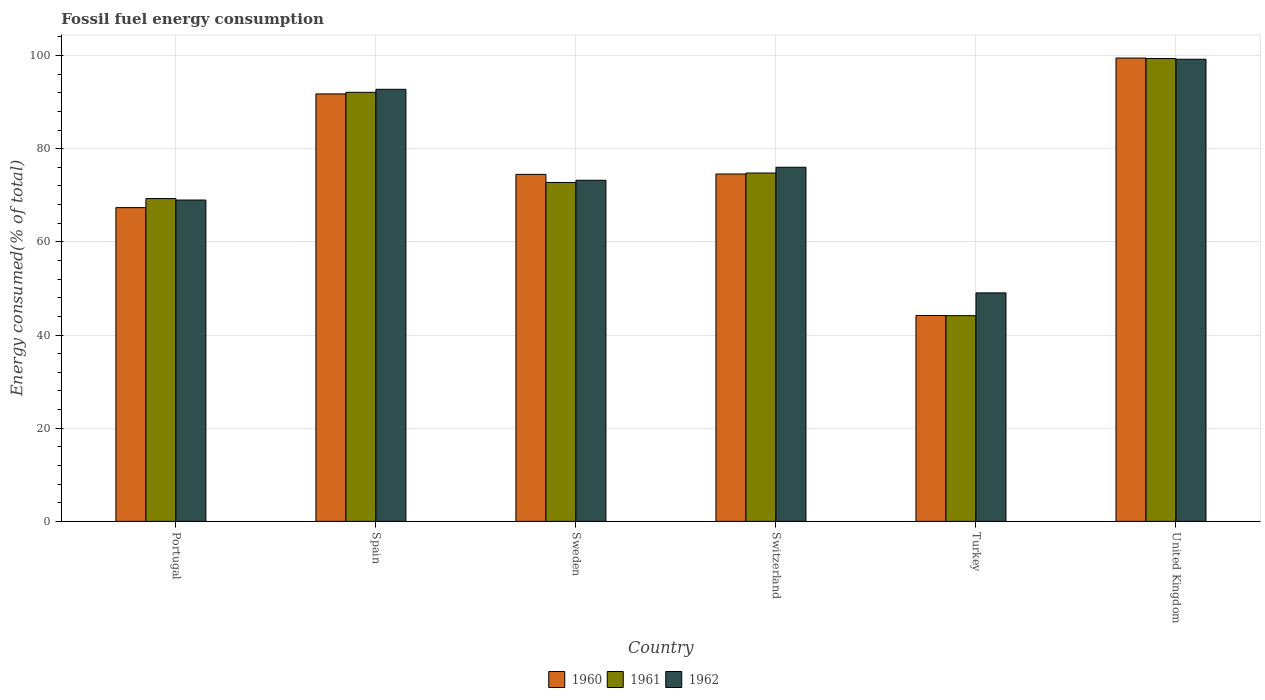How many different coloured bars are there?
Your answer should be very brief. 3. How many groups of bars are there?
Ensure brevity in your answer.  6. Are the number of bars per tick equal to the number of legend labels?
Your response must be concise. Yes. Are the number of bars on each tick of the X-axis equal?
Offer a terse response. Yes. How many bars are there on the 3rd tick from the right?
Keep it short and to the point. 3. What is the label of the 3rd group of bars from the left?
Offer a very short reply. Sweden. In how many cases, is the number of bars for a given country not equal to the number of legend labels?
Provide a short and direct response. 0. What is the percentage of energy consumed in 1960 in Sweden?
Provide a succinct answer. 74.49. Across all countries, what is the maximum percentage of energy consumed in 1961?
Provide a succinct answer. 99.37. Across all countries, what is the minimum percentage of energy consumed in 1961?
Provide a short and direct response. 44.16. In which country was the percentage of energy consumed in 1960 maximum?
Provide a succinct answer. United Kingdom. In which country was the percentage of energy consumed in 1961 minimum?
Provide a succinct answer. Turkey. What is the total percentage of energy consumed in 1960 in the graph?
Make the answer very short. 451.85. What is the difference between the percentage of energy consumed in 1960 in Portugal and that in United Kingdom?
Ensure brevity in your answer.  -32.11. What is the difference between the percentage of energy consumed in 1961 in Switzerland and the percentage of energy consumed in 1960 in Turkey?
Provide a succinct answer. 30.59. What is the average percentage of energy consumed in 1960 per country?
Offer a terse response. 75.31. What is the difference between the percentage of energy consumed of/in 1962 and percentage of energy consumed of/in 1961 in Switzerland?
Give a very brief answer. 1.23. In how many countries, is the percentage of energy consumed in 1960 greater than 40 %?
Offer a terse response. 6. What is the ratio of the percentage of energy consumed in 1960 in Portugal to that in Sweden?
Provide a short and direct response. 0.9. Is the percentage of energy consumed in 1961 in Spain less than that in United Kingdom?
Your answer should be compact. Yes. Is the difference between the percentage of energy consumed in 1962 in Spain and Switzerland greater than the difference between the percentage of energy consumed in 1961 in Spain and Switzerland?
Provide a succinct answer. No. What is the difference between the highest and the second highest percentage of energy consumed in 1961?
Your answer should be very brief. -24.58. What is the difference between the highest and the lowest percentage of energy consumed in 1960?
Provide a succinct answer. 55.27. What does the 2nd bar from the right in Turkey represents?
Your answer should be very brief. 1961. How many bars are there?
Your response must be concise. 18. How many countries are there in the graph?
Your answer should be very brief. 6. Does the graph contain any zero values?
Provide a succinct answer. No. Does the graph contain grids?
Offer a terse response. Yes. How many legend labels are there?
Provide a short and direct response. 3. How are the legend labels stacked?
Your answer should be very brief. Horizontal. What is the title of the graph?
Provide a succinct answer. Fossil fuel energy consumption. Does "2015" appear as one of the legend labels in the graph?
Your response must be concise. No. What is the label or title of the X-axis?
Offer a terse response. Country. What is the label or title of the Y-axis?
Keep it short and to the point. Energy consumed(% of total). What is the Energy consumed(% of total) of 1960 in Portugal?
Your response must be concise. 67.36. What is the Energy consumed(% of total) in 1961 in Portugal?
Ensure brevity in your answer.  69.3. What is the Energy consumed(% of total) in 1962 in Portugal?
Give a very brief answer. 68.98. What is the Energy consumed(% of total) of 1960 in Spain?
Provide a succinct answer. 91.77. What is the Energy consumed(% of total) in 1961 in Spain?
Provide a succinct answer. 92.1. What is the Energy consumed(% of total) of 1962 in Spain?
Ensure brevity in your answer.  92.75. What is the Energy consumed(% of total) of 1960 in Sweden?
Ensure brevity in your answer.  74.49. What is the Energy consumed(% of total) of 1961 in Sweden?
Make the answer very short. 72.75. What is the Energy consumed(% of total) in 1962 in Sweden?
Your answer should be very brief. 73.23. What is the Energy consumed(% of total) of 1960 in Switzerland?
Your response must be concise. 74.57. What is the Energy consumed(% of total) in 1961 in Switzerland?
Your response must be concise. 74.78. What is the Energy consumed(% of total) in 1962 in Switzerland?
Your answer should be very brief. 76.02. What is the Energy consumed(% of total) in 1960 in Turkey?
Give a very brief answer. 44.2. What is the Energy consumed(% of total) of 1961 in Turkey?
Make the answer very short. 44.16. What is the Energy consumed(% of total) of 1962 in Turkey?
Offer a very short reply. 49.05. What is the Energy consumed(% of total) of 1960 in United Kingdom?
Offer a terse response. 99.46. What is the Energy consumed(% of total) in 1961 in United Kingdom?
Offer a very short reply. 99.37. What is the Energy consumed(% of total) in 1962 in United Kingdom?
Make the answer very short. 99.21. Across all countries, what is the maximum Energy consumed(% of total) in 1960?
Offer a terse response. 99.46. Across all countries, what is the maximum Energy consumed(% of total) of 1961?
Your answer should be compact. 99.37. Across all countries, what is the maximum Energy consumed(% of total) of 1962?
Give a very brief answer. 99.21. Across all countries, what is the minimum Energy consumed(% of total) in 1960?
Ensure brevity in your answer.  44.2. Across all countries, what is the minimum Energy consumed(% of total) of 1961?
Offer a very short reply. 44.16. Across all countries, what is the minimum Energy consumed(% of total) in 1962?
Your answer should be very brief. 49.05. What is the total Energy consumed(% of total) of 1960 in the graph?
Make the answer very short. 451.85. What is the total Energy consumed(% of total) in 1961 in the graph?
Provide a succinct answer. 452.46. What is the total Energy consumed(% of total) in 1962 in the graph?
Make the answer very short. 459.23. What is the difference between the Energy consumed(% of total) of 1960 in Portugal and that in Spain?
Ensure brevity in your answer.  -24.41. What is the difference between the Energy consumed(% of total) in 1961 in Portugal and that in Spain?
Your response must be concise. -22.81. What is the difference between the Energy consumed(% of total) of 1962 in Portugal and that in Spain?
Offer a terse response. -23.77. What is the difference between the Energy consumed(% of total) of 1960 in Portugal and that in Sweden?
Keep it short and to the point. -7.14. What is the difference between the Energy consumed(% of total) of 1961 in Portugal and that in Sweden?
Offer a terse response. -3.46. What is the difference between the Energy consumed(% of total) in 1962 in Portugal and that in Sweden?
Your answer should be very brief. -4.25. What is the difference between the Energy consumed(% of total) of 1960 in Portugal and that in Switzerland?
Your response must be concise. -7.22. What is the difference between the Energy consumed(% of total) in 1961 in Portugal and that in Switzerland?
Keep it short and to the point. -5.49. What is the difference between the Energy consumed(% of total) of 1962 in Portugal and that in Switzerland?
Provide a succinct answer. -7.04. What is the difference between the Energy consumed(% of total) of 1960 in Portugal and that in Turkey?
Make the answer very short. 23.16. What is the difference between the Energy consumed(% of total) in 1961 in Portugal and that in Turkey?
Your answer should be very brief. 25.14. What is the difference between the Energy consumed(% of total) of 1962 in Portugal and that in Turkey?
Your answer should be very brief. 19.93. What is the difference between the Energy consumed(% of total) in 1960 in Portugal and that in United Kingdom?
Your response must be concise. -32.11. What is the difference between the Energy consumed(% of total) in 1961 in Portugal and that in United Kingdom?
Your response must be concise. -30.07. What is the difference between the Energy consumed(% of total) of 1962 in Portugal and that in United Kingdom?
Provide a short and direct response. -30.23. What is the difference between the Energy consumed(% of total) in 1960 in Spain and that in Sweden?
Give a very brief answer. 17.27. What is the difference between the Energy consumed(% of total) in 1961 in Spain and that in Sweden?
Make the answer very short. 19.35. What is the difference between the Energy consumed(% of total) in 1962 in Spain and that in Sweden?
Your answer should be very brief. 19.53. What is the difference between the Energy consumed(% of total) in 1960 in Spain and that in Switzerland?
Make the answer very short. 17.19. What is the difference between the Energy consumed(% of total) of 1961 in Spain and that in Switzerland?
Keep it short and to the point. 17.32. What is the difference between the Energy consumed(% of total) in 1962 in Spain and that in Switzerland?
Your answer should be very brief. 16.74. What is the difference between the Energy consumed(% of total) of 1960 in Spain and that in Turkey?
Provide a succinct answer. 47.57. What is the difference between the Energy consumed(% of total) of 1961 in Spain and that in Turkey?
Provide a short and direct response. 47.95. What is the difference between the Energy consumed(% of total) of 1962 in Spain and that in Turkey?
Keep it short and to the point. 43.7. What is the difference between the Energy consumed(% of total) of 1960 in Spain and that in United Kingdom?
Provide a short and direct response. -7.7. What is the difference between the Energy consumed(% of total) of 1961 in Spain and that in United Kingdom?
Make the answer very short. -7.26. What is the difference between the Energy consumed(% of total) of 1962 in Spain and that in United Kingdom?
Offer a very short reply. -6.45. What is the difference between the Energy consumed(% of total) in 1960 in Sweden and that in Switzerland?
Your answer should be very brief. -0.08. What is the difference between the Energy consumed(% of total) of 1961 in Sweden and that in Switzerland?
Provide a succinct answer. -2.03. What is the difference between the Energy consumed(% of total) of 1962 in Sweden and that in Switzerland?
Keep it short and to the point. -2.79. What is the difference between the Energy consumed(% of total) in 1960 in Sweden and that in Turkey?
Keep it short and to the point. 30.29. What is the difference between the Energy consumed(% of total) of 1961 in Sweden and that in Turkey?
Your response must be concise. 28.59. What is the difference between the Energy consumed(% of total) in 1962 in Sweden and that in Turkey?
Your response must be concise. 24.18. What is the difference between the Energy consumed(% of total) of 1960 in Sweden and that in United Kingdom?
Provide a short and direct response. -24.97. What is the difference between the Energy consumed(% of total) of 1961 in Sweden and that in United Kingdom?
Provide a short and direct response. -26.61. What is the difference between the Energy consumed(% of total) of 1962 in Sweden and that in United Kingdom?
Keep it short and to the point. -25.98. What is the difference between the Energy consumed(% of total) in 1960 in Switzerland and that in Turkey?
Make the answer very short. 30.37. What is the difference between the Energy consumed(% of total) of 1961 in Switzerland and that in Turkey?
Keep it short and to the point. 30.62. What is the difference between the Energy consumed(% of total) in 1962 in Switzerland and that in Turkey?
Make the answer very short. 26.97. What is the difference between the Energy consumed(% of total) of 1960 in Switzerland and that in United Kingdom?
Offer a very short reply. -24.89. What is the difference between the Energy consumed(% of total) of 1961 in Switzerland and that in United Kingdom?
Make the answer very short. -24.58. What is the difference between the Energy consumed(% of total) in 1962 in Switzerland and that in United Kingdom?
Give a very brief answer. -23.19. What is the difference between the Energy consumed(% of total) in 1960 in Turkey and that in United Kingdom?
Your answer should be very brief. -55.27. What is the difference between the Energy consumed(% of total) of 1961 in Turkey and that in United Kingdom?
Your answer should be very brief. -55.21. What is the difference between the Energy consumed(% of total) in 1962 in Turkey and that in United Kingdom?
Offer a terse response. -50.16. What is the difference between the Energy consumed(% of total) of 1960 in Portugal and the Energy consumed(% of total) of 1961 in Spain?
Offer a terse response. -24.75. What is the difference between the Energy consumed(% of total) of 1960 in Portugal and the Energy consumed(% of total) of 1962 in Spain?
Provide a succinct answer. -25.4. What is the difference between the Energy consumed(% of total) in 1961 in Portugal and the Energy consumed(% of total) in 1962 in Spain?
Your answer should be very brief. -23.46. What is the difference between the Energy consumed(% of total) in 1960 in Portugal and the Energy consumed(% of total) in 1961 in Sweden?
Give a very brief answer. -5.4. What is the difference between the Energy consumed(% of total) of 1960 in Portugal and the Energy consumed(% of total) of 1962 in Sweden?
Offer a terse response. -5.87. What is the difference between the Energy consumed(% of total) of 1961 in Portugal and the Energy consumed(% of total) of 1962 in Sweden?
Provide a short and direct response. -3.93. What is the difference between the Energy consumed(% of total) of 1960 in Portugal and the Energy consumed(% of total) of 1961 in Switzerland?
Your answer should be very brief. -7.43. What is the difference between the Energy consumed(% of total) of 1960 in Portugal and the Energy consumed(% of total) of 1962 in Switzerland?
Offer a very short reply. -8.66. What is the difference between the Energy consumed(% of total) in 1961 in Portugal and the Energy consumed(% of total) in 1962 in Switzerland?
Offer a very short reply. -6.72. What is the difference between the Energy consumed(% of total) in 1960 in Portugal and the Energy consumed(% of total) in 1961 in Turkey?
Provide a short and direct response. 23.2. What is the difference between the Energy consumed(% of total) of 1960 in Portugal and the Energy consumed(% of total) of 1962 in Turkey?
Your answer should be very brief. 18.31. What is the difference between the Energy consumed(% of total) of 1961 in Portugal and the Energy consumed(% of total) of 1962 in Turkey?
Your response must be concise. 20.25. What is the difference between the Energy consumed(% of total) of 1960 in Portugal and the Energy consumed(% of total) of 1961 in United Kingdom?
Offer a terse response. -32.01. What is the difference between the Energy consumed(% of total) of 1960 in Portugal and the Energy consumed(% of total) of 1962 in United Kingdom?
Provide a short and direct response. -31.85. What is the difference between the Energy consumed(% of total) in 1961 in Portugal and the Energy consumed(% of total) in 1962 in United Kingdom?
Your answer should be very brief. -29.91. What is the difference between the Energy consumed(% of total) in 1960 in Spain and the Energy consumed(% of total) in 1961 in Sweden?
Provide a short and direct response. 19.01. What is the difference between the Energy consumed(% of total) in 1960 in Spain and the Energy consumed(% of total) in 1962 in Sweden?
Offer a terse response. 18.54. What is the difference between the Energy consumed(% of total) in 1961 in Spain and the Energy consumed(% of total) in 1962 in Sweden?
Offer a very short reply. 18.88. What is the difference between the Energy consumed(% of total) of 1960 in Spain and the Energy consumed(% of total) of 1961 in Switzerland?
Make the answer very short. 16.98. What is the difference between the Energy consumed(% of total) of 1960 in Spain and the Energy consumed(% of total) of 1962 in Switzerland?
Provide a succinct answer. 15.75. What is the difference between the Energy consumed(% of total) in 1961 in Spain and the Energy consumed(% of total) in 1962 in Switzerland?
Your answer should be very brief. 16.09. What is the difference between the Energy consumed(% of total) in 1960 in Spain and the Energy consumed(% of total) in 1961 in Turkey?
Give a very brief answer. 47.61. What is the difference between the Energy consumed(% of total) of 1960 in Spain and the Energy consumed(% of total) of 1962 in Turkey?
Provide a succinct answer. 42.72. What is the difference between the Energy consumed(% of total) of 1961 in Spain and the Energy consumed(% of total) of 1962 in Turkey?
Provide a succinct answer. 43.05. What is the difference between the Energy consumed(% of total) of 1960 in Spain and the Energy consumed(% of total) of 1961 in United Kingdom?
Keep it short and to the point. -7.6. What is the difference between the Energy consumed(% of total) in 1960 in Spain and the Energy consumed(% of total) in 1962 in United Kingdom?
Keep it short and to the point. -7.44. What is the difference between the Energy consumed(% of total) in 1961 in Spain and the Energy consumed(% of total) in 1962 in United Kingdom?
Your response must be concise. -7.1. What is the difference between the Energy consumed(% of total) in 1960 in Sweden and the Energy consumed(% of total) in 1961 in Switzerland?
Make the answer very short. -0.29. What is the difference between the Energy consumed(% of total) of 1960 in Sweden and the Energy consumed(% of total) of 1962 in Switzerland?
Make the answer very short. -1.52. What is the difference between the Energy consumed(% of total) of 1961 in Sweden and the Energy consumed(% of total) of 1962 in Switzerland?
Offer a terse response. -3.26. What is the difference between the Energy consumed(% of total) of 1960 in Sweden and the Energy consumed(% of total) of 1961 in Turkey?
Offer a very short reply. 30.33. What is the difference between the Energy consumed(% of total) of 1960 in Sweden and the Energy consumed(% of total) of 1962 in Turkey?
Your response must be concise. 25.44. What is the difference between the Energy consumed(% of total) in 1961 in Sweden and the Energy consumed(% of total) in 1962 in Turkey?
Your answer should be compact. 23.7. What is the difference between the Energy consumed(% of total) of 1960 in Sweden and the Energy consumed(% of total) of 1961 in United Kingdom?
Make the answer very short. -24.87. What is the difference between the Energy consumed(% of total) of 1960 in Sweden and the Energy consumed(% of total) of 1962 in United Kingdom?
Your response must be concise. -24.71. What is the difference between the Energy consumed(% of total) of 1961 in Sweden and the Energy consumed(% of total) of 1962 in United Kingdom?
Give a very brief answer. -26.45. What is the difference between the Energy consumed(% of total) of 1960 in Switzerland and the Energy consumed(% of total) of 1961 in Turkey?
Provide a succinct answer. 30.41. What is the difference between the Energy consumed(% of total) in 1960 in Switzerland and the Energy consumed(% of total) in 1962 in Turkey?
Offer a very short reply. 25.52. What is the difference between the Energy consumed(% of total) in 1961 in Switzerland and the Energy consumed(% of total) in 1962 in Turkey?
Offer a terse response. 25.73. What is the difference between the Energy consumed(% of total) of 1960 in Switzerland and the Energy consumed(% of total) of 1961 in United Kingdom?
Your answer should be very brief. -24.8. What is the difference between the Energy consumed(% of total) of 1960 in Switzerland and the Energy consumed(% of total) of 1962 in United Kingdom?
Keep it short and to the point. -24.64. What is the difference between the Energy consumed(% of total) of 1961 in Switzerland and the Energy consumed(% of total) of 1962 in United Kingdom?
Offer a very short reply. -24.42. What is the difference between the Energy consumed(% of total) of 1960 in Turkey and the Energy consumed(% of total) of 1961 in United Kingdom?
Ensure brevity in your answer.  -55.17. What is the difference between the Energy consumed(% of total) in 1960 in Turkey and the Energy consumed(% of total) in 1962 in United Kingdom?
Keep it short and to the point. -55.01. What is the difference between the Energy consumed(% of total) of 1961 in Turkey and the Energy consumed(% of total) of 1962 in United Kingdom?
Offer a very short reply. -55.05. What is the average Energy consumed(% of total) of 1960 per country?
Make the answer very short. 75.31. What is the average Energy consumed(% of total) in 1961 per country?
Your answer should be compact. 75.41. What is the average Energy consumed(% of total) in 1962 per country?
Keep it short and to the point. 76.54. What is the difference between the Energy consumed(% of total) of 1960 and Energy consumed(% of total) of 1961 in Portugal?
Offer a very short reply. -1.94. What is the difference between the Energy consumed(% of total) in 1960 and Energy consumed(% of total) in 1962 in Portugal?
Give a very brief answer. -1.62. What is the difference between the Energy consumed(% of total) of 1961 and Energy consumed(% of total) of 1962 in Portugal?
Your answer should be very brief. 0.32. What is the difference between the Energy consumed(% of total) of 1960 and Energy consumed(% of total) of 1961 in Spain?
Keep it short and to the point. -0.34. What is the difference between the Energy consumed(% of total) in 1960 and Energy consumed(% of total) in 1962 in Spain?
Your answer should be very brief. -0.99. What is the difference between the Energy consumed(% of total) of 1961 and Energy consumed(% of total) of 1962 in Spain?
Your answer should be very brief. -0.65. What is the difference between the Energy consumed(% of total) in 1960 and Energy consumed(% of total) in 1961 in Sweden?
Your response must be concise. 1.74. What is the difference between the Energy consumed(% of total) in 1960 and Energy consumed(% of total) in 1962 in Sweden?
Provide a succinct answer. 1.27. What is the difference between the Energy consumed(% of total) in 1961 and Energy consumed(% of total) in 1962 in Sweden?
Your response must be concise. -0.47. What is the difference between the Energy consumed(% of total) in 1960 and Energy consumed(% of total) in 1961 in Switzerland?
Keep it short and to the point. -0.21. What is the difference between the Energy consumed(% of total) in 1960 and Energy consumed(% of total) in 1962 in Switzerland?
Your response must be concise. -1.45. What is the difference between the Energy consumed(% of total) in 1961 and Energy consumed(% of total) in 1962 in Switzerland?
Your response must be concise. -1.23. What is the difference between the Energy consumed(% of total) of 1960 and Energy consumed(% of total) of 1961 in Turkey?
Give a very brief answer. 0.04. What is the difference between the Energy consumed(% of total) of 1960 and Energy consumed(% of total) of 1962 in Turkey?
Give a very brief answer. -4.85. What is the difference between the Energy consumed(% of total) in 1961 and Energy consumed(% of total) in 1962 in Turkey?
Provide a succinct answer. -4.89. What is the difference between the Energy consumed(% of total) in 1960 and Energy consumed(% of total) in 1961 in United Kingdom?
Ensure brevity in your answer.  0.1. What is the difference between the Energy consumed(% of total) of 1960 and Energy consumed(% of total) of 1962 in United Kingdom?
Offer a very short reply. 0.26. What is the difference between the Energy consumed(% of total) in 1961 and Energy consumed(% of total) in 1962 in United Kingdom?
Provide a succinct answer. 0.16. What is the ratio of the Energy consumed(% of total) of 1960 in Portugal to that in Spain?
Your answer should be very brief. 0.73. What is the ratio of the Energy consumed(% of total) of 1961 in Portugal to that in Spain?
Ensure brevity in your answer.  0.75. What is the ratio of the Energy consumed(% of total) of 1962 in Portugal to that in Spain?
Keep it short and to the point. 0.74. What is the ratio of the Energy consumed(% of total) in 1960 in Portugal to that in Sweden?
Give a very brief answer. 0.9. What is the ratio of the Energy consumed(% of total) in 1961 in Portugal to that in Sweden?
Give a very brief answer. 0.95. What is the ratio of the Energy consumed(% of total) in 1962 in Portugal to that in Sweden?
Give a very brief answer. 0.94. What is the ratio of the Energy consumed(% of total) in 1960 in Portugal to that in Switzerland?
Keep it short and to the point. 0.9. What is the ratio of the Energy consumed(% of total) in 1961 in Portugal to that in Switzerland?
Your response must be concise. 0.93. What is the ratio of the Energy consumed(% of total) in 1962 in Portugal to that in Switzerland?
Your answer should be compact. 0.91. What is the ratio of the Energy consumed(% of total) of 1960 in Portugal to that in Turkey?
Your response must be concise. 1.52. What is the ratio of the Energy consumed(% of total) of 1961 in Portugal to that in Turkey?
Offer a very short reply. 1.57. What is the ratio of the Energy consumed(% of total) in 1962 in Portugal to that in Turkey?
Your answer should be compact. 1.41. What is the ratio of the Energy consumed(% of total) in 1960 in Portugal to that in United Kingdom?
Keep it short and to the point. 0.68. What is the ratio of the Energy consumed(% of total) in 1961 in Portugal to that in United Kingdom?
Make the answer very short. 0.7. What is the ratio of the Energy consumed(% of total) in 1962 in Portugal to that in United Kingdom?
Provide a short and direct response. 0.7. What is the ratio of the Energy consumed(% of total) of 1960 in Spain to that in Sweden?
Provide a short and direct response. 1.23. What is the ratio of the Energy consumed(% of total) in 1961 in Spain to that in Sweden?
Your answer should be compact. 1.27. What is the ratio of the Energy consumed(% of total) of 1962 in Spain to that in Sweden?
Your answer should be very brief. 1.27. What is the ratio of the Energy consumed(% of total) in 1960 in Spain to that in Switzerland?
Make the answer very short. 1.23. What is the ratio of the Energy consumed(% of total) of 1961 in Spain to that in Switzerland?
Keep it short and to the point. 1.23. What is the ratio of the Energy consumed(% of total) in 1962 in Spain to that in Switzerland?
Your response must be concise. 1.22. What is the ratio of the Energy consumed(% of total) of 1960 in Spain to that in Turkey?
Your response must be concise. 2.08. What is the ratio of the Energy consumed(% of total) of 1961 in Spain to that in Turkey?
Offer a very short reply. 2.09. What is the ratio of the Energy consumed(% of total) in 1962 in Spain to that in Turkey?
Your response must be concise. 1.89. What is the ratio of the Energy consumed(% of total) of 1960 in Spain to that in United Kingdom?
Provide a short and direct response. 0.92. What is the ratio of the Energy consumed(% of total) in 1961 in Spain to that in United Kingdom?
Keep it short and to the point. 0.93. What is the ratio of the Energy consumed(% of total) in 1962 in Spain to that in United Kingdom?
Give a very brief answer. 0.93. What is the ratio of the Energy consumed(% of total) of 1960 in Sweden to that in Switzerland?
Make the answer very short. 1. What is the ratio of the Energy consumed(% of total) of 1961 in Sweden to that in Switzerland?
Offer a terse response. 0.97. What is the ratio of the Energy consumed(% of total) of 1962 in Sweden to that in Switzerland?
Provide a succinct answer. 0.96. What is the ratio of the Energy consumed(% of total) in 1960 in Sweden to that in Turkey?
Keep it short and to the point. 1.69. What is the ratio of the Energy consumed(% of total) of 1961 in Sweden to that in Turkey?
Your answer should be very brief. 1.65. What is the ratio of the Energy consumed(% of total) of 1962 in Sweden to that in Turkey?
Provide a succinct answer. 1.49. What is the ratio of the Energy consumed(% of total) of 1960 in Sweden to that in United Kingdom?
Provide a succinct answer. 0.75. What is the ratio of the Energy consumed(% of total) in 1961 in Sweden to that in United Kingdom?
Your answer should be compact. 0.73. What is the ratio of the Energy consumed(% of total) in 1962 in Sweden to that in United Kingdom?
Your answer should be compact. 0.74. What is the ratio of the Energy consumed(% of total) of 1960 in Switzerland to that in Turkey?
Offer a terse response. 1.69. What is the ratio of the Energy consumed(% of total) in 1961 in Switzerland to that in Turkey?
Give a very brief answer. 1.69. What is the ratio of the Energy consumed(% of total) in 1962 in Switzerland to that in Turkey?
Your answer should be compact. 1.55. What is the ratio of the Energy consumed(% of total) of 1960 in Switzerland to that in United Kingdom?
Give a very brief answer. 0.75. What is the ratio of the Energy consumed(% of total) of 1961 in Switzerland to that in United Kingdom?
Provide a short and direct response. 0.75. What is the ratio of the Energy consumed(% of total) in 1962 in Switzerland to that in United Kingdom?
Your response must be concise. 0.77. What is the ratio of the Energy consumed(% of total) in 1960 in Turkey to that in United Kingdom?
Ensure brevity in your answer.  0.44. What is the ratio of the Energy consumed(% of total) of 1961 in Turkey to that in United Kingdom?
Ensure brevity in your answer.  0.44. What is the ratio of the Energy consumed(% of total) in 1962 in Turkey to that in United Kingdom?
Provide a short and direct response. 0.49. What is the difference between the highest and the second highest Energy consumed(% of total) in 1960?
Provide a short and direct response. 7.7. What is the difference between the highest and the second highest Energy consumed(% of total) in 1961?
Give a very brief answer. 7.26. What is the difference between the highest and the second highest Energy consumed(% of total) in 1962?
Give a very brief answer. 6.45. What is the difference between the highest and the lowest Energy consumed(% of total) of 1960?
Keep it short and to the point. 55.27. What is the difference between the highest and the lowest Energy consumed(% of total) of 1961?
Your response must be concise. 55.21. What is the difference between the highest and the lowest Energy consumed(% of total) in 1962?
Your answer should be compact. 50.16. 